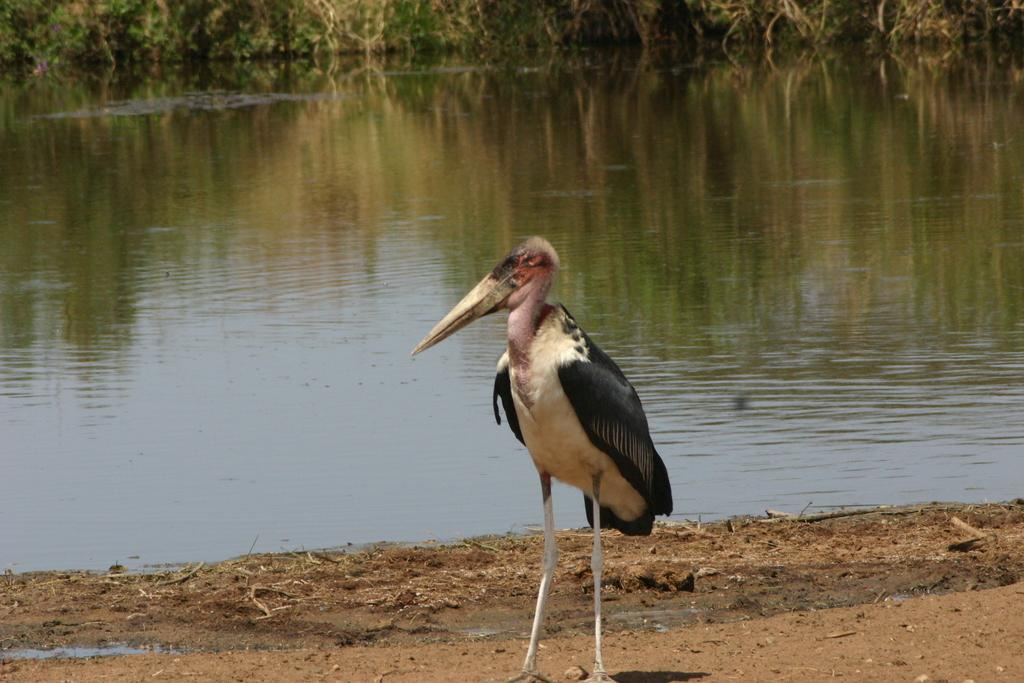What is the main subject of the image? The main subject of the image is a crane. Where is the crane located in the image? The crane is standing on the land in the image. What is the color scheme of the land? The land is in white and black color. What can be seen in the background of the image? There is a pond in the background of the image. Can you see a dog playing with a piece of flesh in the image? There is no dog or flesh present in the image; it features a crane standing on the land with a pond in the background. 